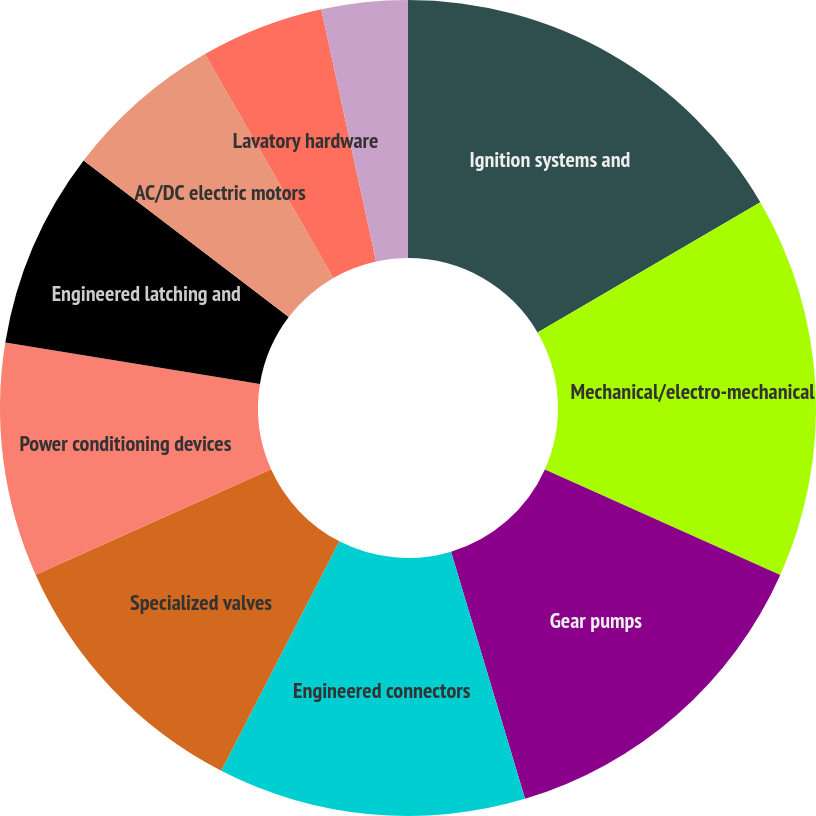<chart> <loc_0><loc_0><loc_500><loc_500><pie_chart><fcel>Ignition systems and<fcel>Mechanical/electro-mechanical<fcel>Gear pumps<fcel>Engineered connectors<fcel>Specialized valves<fcel>Power conditioning devices<fcel>Engineered latching and<fcel>AC/DC electric motors<fcel>Lavatory hardware<fcel>Rods and locking devices<nl><fcel>16.59%<fcel>15.12%<fcel>13.66%<fcel>12.2%<fcel>10.73%<fcel>9.27%<fcel>7.8%<fcel>6.34%<fcel>4.88%<fcel>3.41%<nl></chart> 